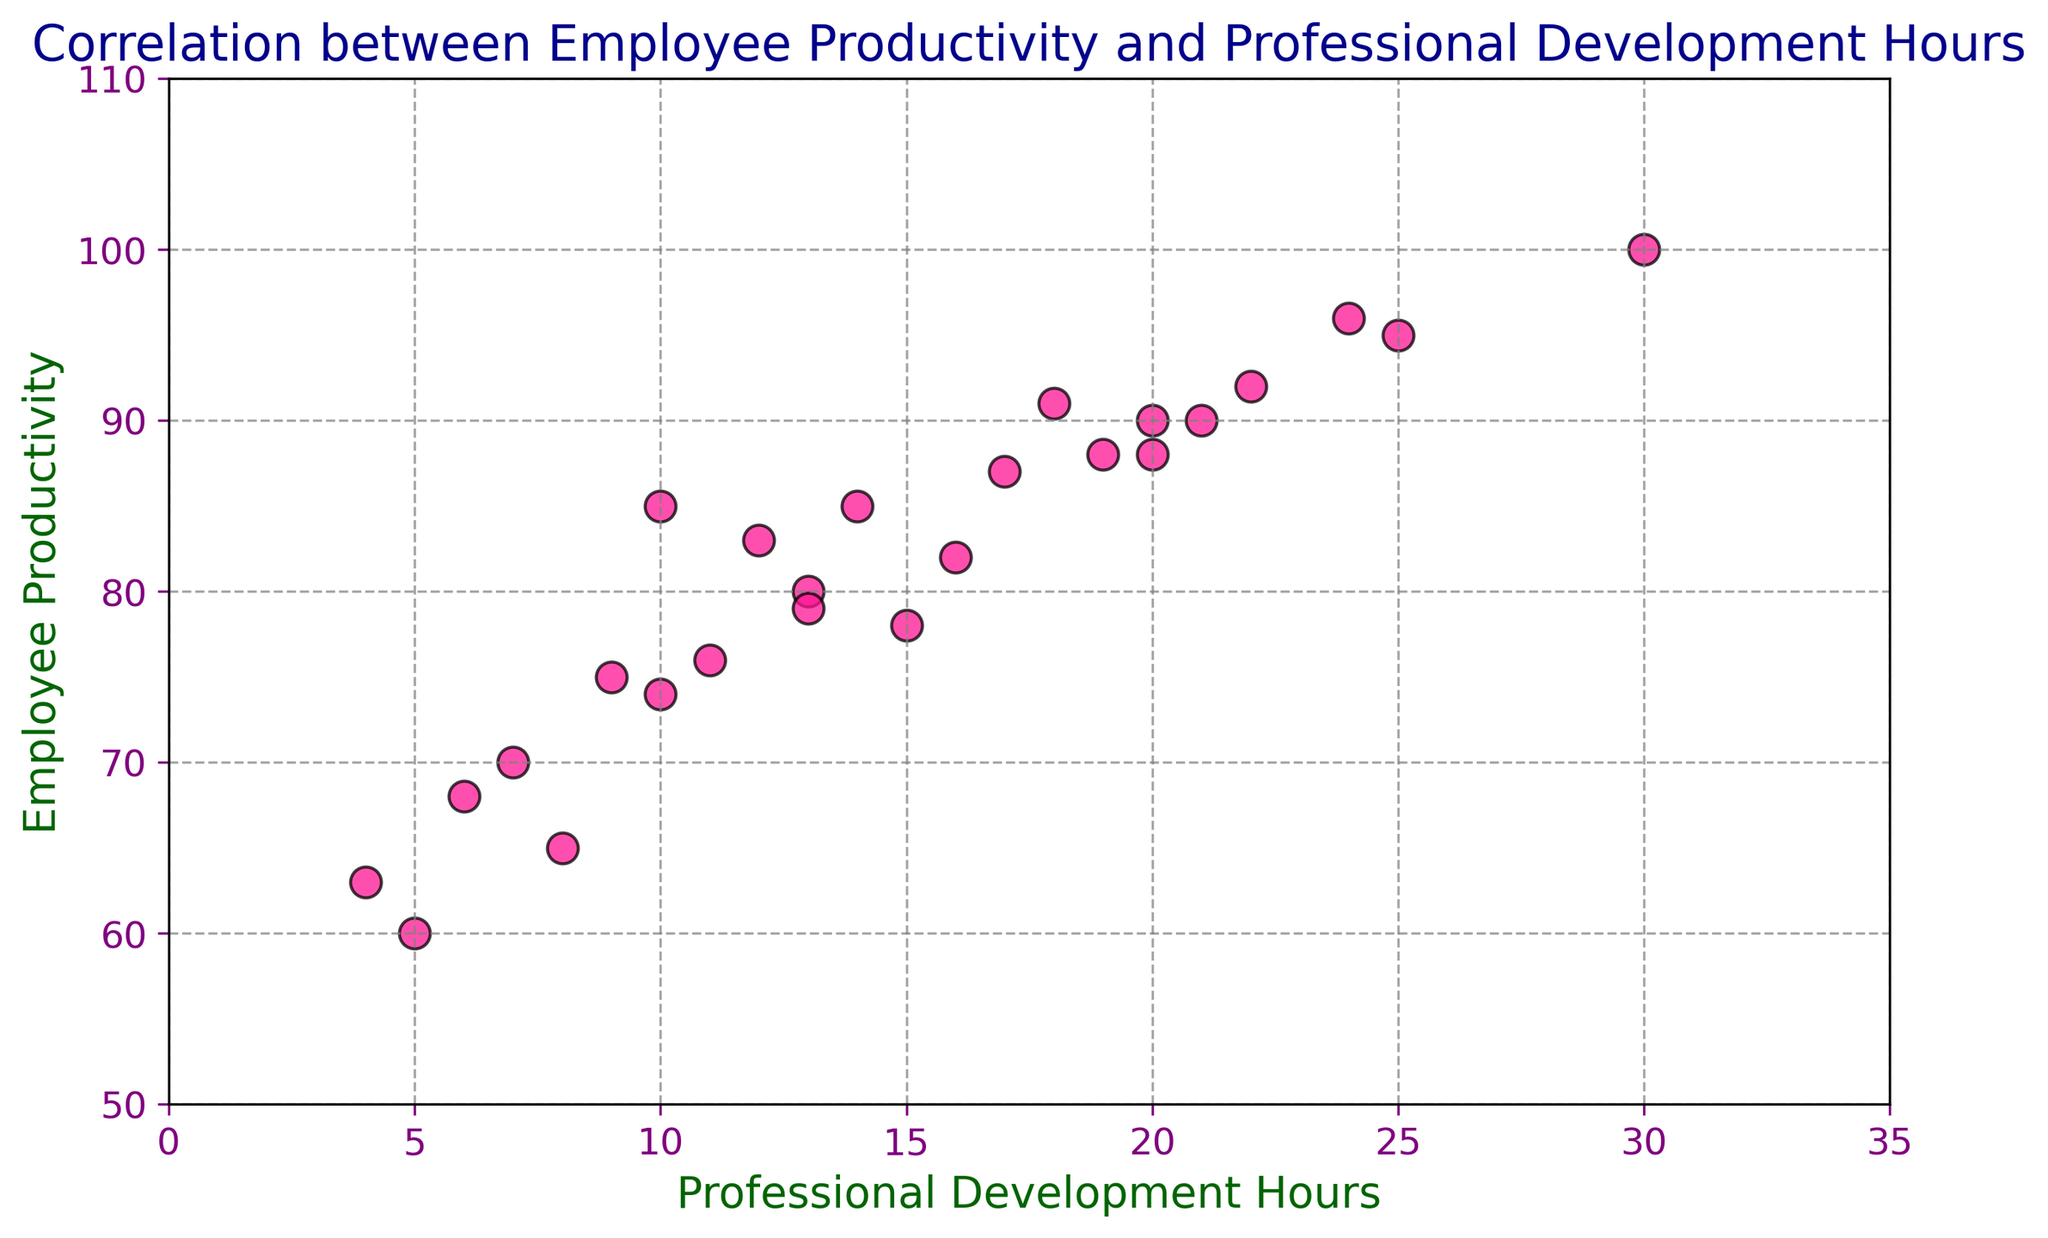What's the correlation between professional development hours and employee productivity? From the scatter plot, you can observe that as professional development hours increase, there is a tendency for employee productivity to also increase, indicating a positive correlation.
Answer: Positive correlation Which employee has the highest productivity, and how many professional development hours do they have? The data point with the highest productivity is 100, which corresponds to 30 professional development hours.
Answer: Employee with 100 productivity and 30 development hours Are there any outliers in the scatter plot that deviate significantly from the trend? Most data points lie along a general trendline showing positive correlation, but a point with 60 productivity at 5 hours seems relatively lower compared to the trend.
Answer: 60 productivity at 5 hours What is the average employee productivity for those who had 15 or more hours of professional development? From the data points with 15 or more hours (78, 90, 92, 88, 95, 80, 100, 85, 90, 96, 82, 88, 79, 91, 87), sum them up to get 1291, and divide by 15 (number of points) to get 86.07.
Answer: 86.07 Comparing employees with less than 10 hours and those with more than 20 hours of professional development, which group has higher productivity on average? Calculate the average for the first group: (85+60+70+75+65+68+63)/7 = 69.43, and for the second group: (95+92+90+96+100+90)/6 = 93.83. The second group has higher productivity.
Answer: Group with more than 20 hours How many employees have productivity above 90 and what are their professional development hours? From the plot, the productivity values above 90 are: 100, 95, 92, 96, 91, 90. Corresponding hours are: 30, 25, 22, 24, 18, 20.
Answer: 6 employees with 30, 25, 22, 24, 18, and 20 hours What is the productivity range for employees with between 10 and 20 hours of professional development? For the range (10-20 hours): values are 85, 78, 88, 80, 85, 76, 90, 83, 74, 82, 88, 79. Min is 74 and max is 90.
Answer: 74 to 90 What can we infer about the productivity of employees with less than 10 hours of professional development? Observing the scatter plot, employees with less than 10 hours have productivity values spread between 60 and 75, generally lower compared to those with more hours.
Answer: 60 to 75, generally lower 